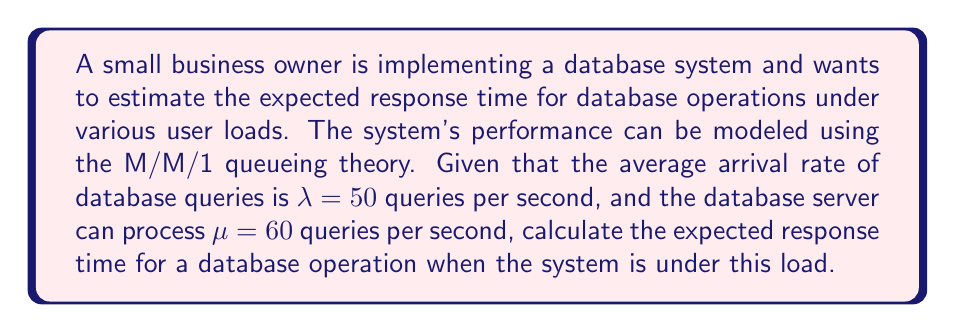Can you solve this math problem? To solve this problem, we'll use the M/M/1 queueing theory model, which is appropriate for a single-server system with Poisson arrival rates and exponential service times.

1. First, we need to calculate the system utilization (ρ):
   $$\rho = \frac{\lambda}{\mu}$$
   $$\rho = \frac{50}{60} = \frac{5}{6} \approx 0.833$$

2. The expected time a query spends in the system (W) is given by the formula:
   $$W = \frac{1}{\mu - \lambda}$$

3. Substituting the values:
   $$W = \frac{1}{60 - 50} = \frac{1}{10} = 0.1 \text{ seconds}$$

4. This result includes both the time spent waiting in the queue and the time spent being processed. To break it down:

   a. Expected time in queue (Wq):
      $$W_q = \frac{\rho}{\mu - \lambda} = \frac{5/6}{10} = \frac{1}{12} \approx 0.0833 \text{ seconds}$$

   b. Expected service time (Ws):
      $$W_s = \frac{1}{\mu} = \frac{1}{60} \approx 0.0167 \text{ seconds}$$

   Note that W = Wq + Ws = 0.0833 + 0.0167 = 0.1 seconds, which confirms our calculation.

5. Therefore, the expected response time for a database operation under this load is 0.1 seconds or 100 milliseconds.
Answer: The expected response time for a database operation under the given load is 0.1 seconds (100 milliseconds). 